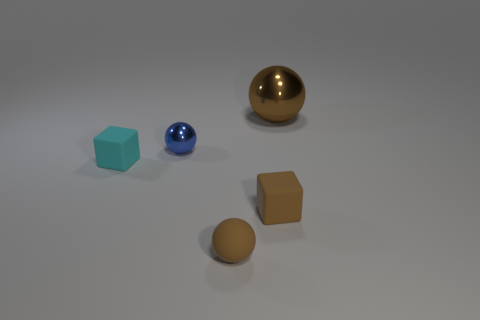Does the large thing that is on the right side of the small brown rubber cube have the same color as the block right of the cyan matte thing?
Provide a short and direct response. Yes. What material is the small ball that is the same color as the large thing?
Your response must be concise. Rubber. Are there any tiny things of the same color as the big sphere?
Keep it short and to the point. Yes. What number of other things are the same color as the big object?
Ensure brevity in your answer.  2. How many objects are brown spheres that are left of the large sphere or brown spheres?
Provide a short and direct response. 2. Is the number of small blue things behind the tiny metal sphere less than the number of small brown matte objects behind the large brown ball?
Your response must be concise. No. There is a tiny cyan rubber cube; are there any brown objects behind it?
Ensure brevity in your answer.  Yes. What number of things are either blue shiny balls that are to the left of the brown rubber ball or tiny cubes that are on the left side of the tiny blue sphere?
Offer a terse response. 2. How many small matte things have the same color as the big metallic object?
Provide a succinct answer. 2. What color is the other small matte object that is the same shape as the cyan thing?
Give a very brief answer. Brown. 